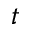<formula> <loc_0><loc_0><loc_500><loc_500>t</formula> 